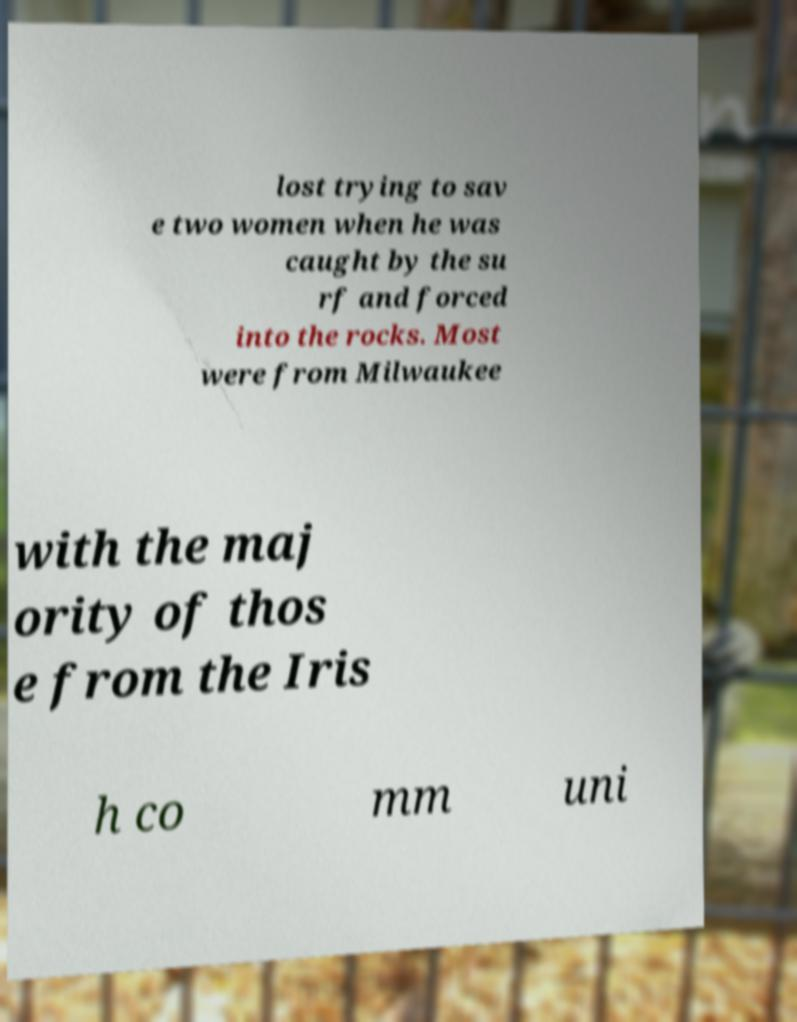Can you read and provide the text displayed in the image?This photo seems to have some interesting text. Can you extract and type it out for me? lost trying to sav e two women when he was caught by the su rf and forced into the rocks. Most were from Milwaukee with the maj ority of thos e from the Iris h co mm uni 